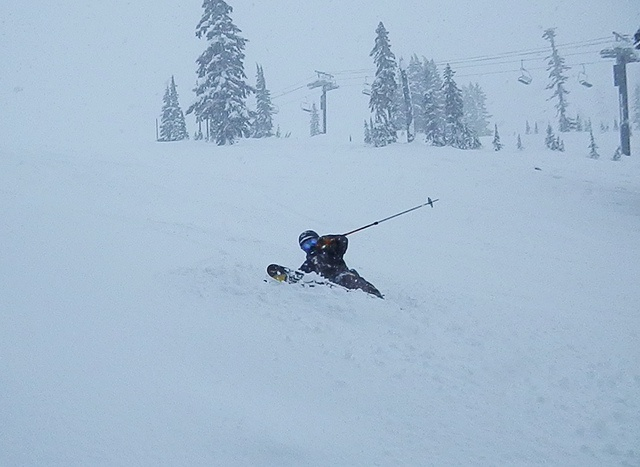Describe the objects in this image and their specific colors. I can see people in lightblue, black, navy, gray, and darkblue tones, snowboard in lightblue, darkgray, gray, and navy tones, and skis in lightblue, gray, navy, black, and darkgray tones in this image. 